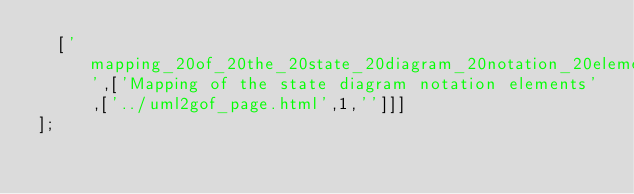Convert code to text. <code><loc_0><loc_0><loc_500><loc_500><_JavaScript_>  ['mapping_20of_20the_20state_20diagram_20notation_20elements',['Mapping of the state diagram notation elements',['../uml2gof_page.html',1,'']]]
];
</code> 